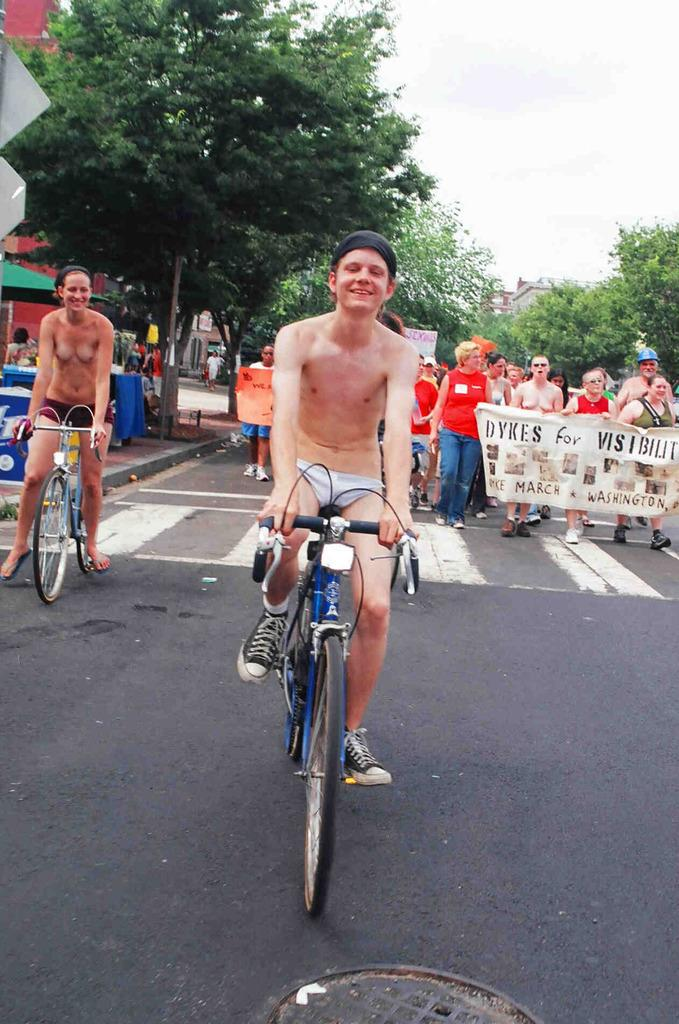What is the man in the image doing? The man is riding a bicycle in the image. Where is the bicycle located? The bicycle is on the road in the image. What can be seen in the background of the image? There are people and trees in the background of the image. What type of tank can be seen in the image? There is no tank present in the image; it features a man riding a bicycle on the road. How does the man start riding the bicycle in the image? The image does not show the man starting to ride the bicycle, so it cannot be determined from the image. 